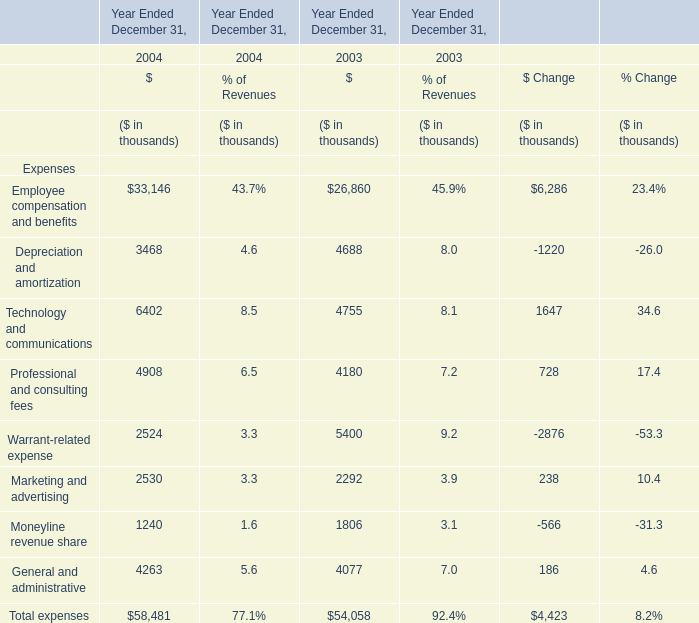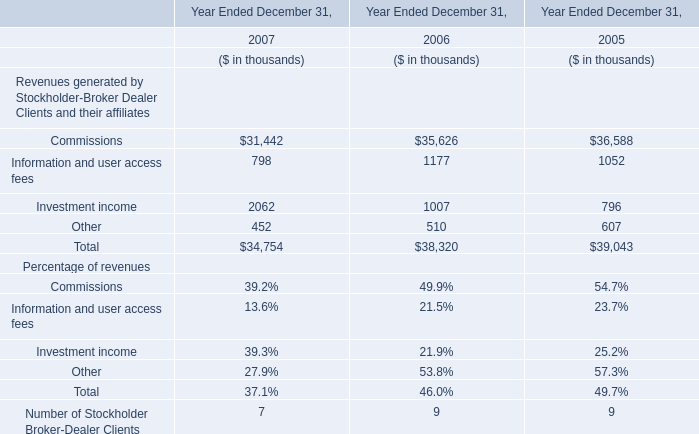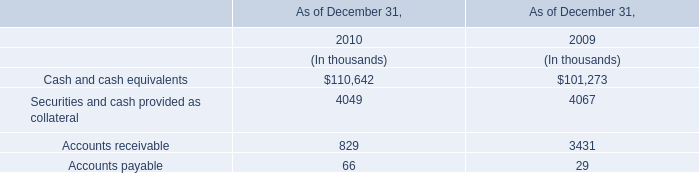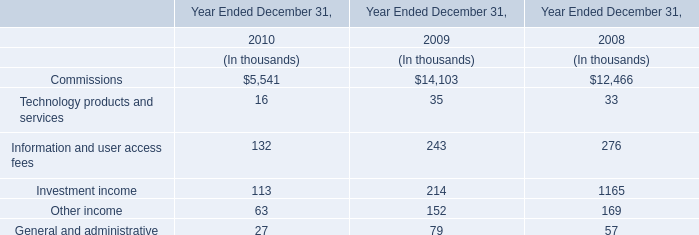What's the growth rate of Technology and communications in 2004? 
Computations: ((6402 - 4755) / 4755)
Answer: 0.34637. 